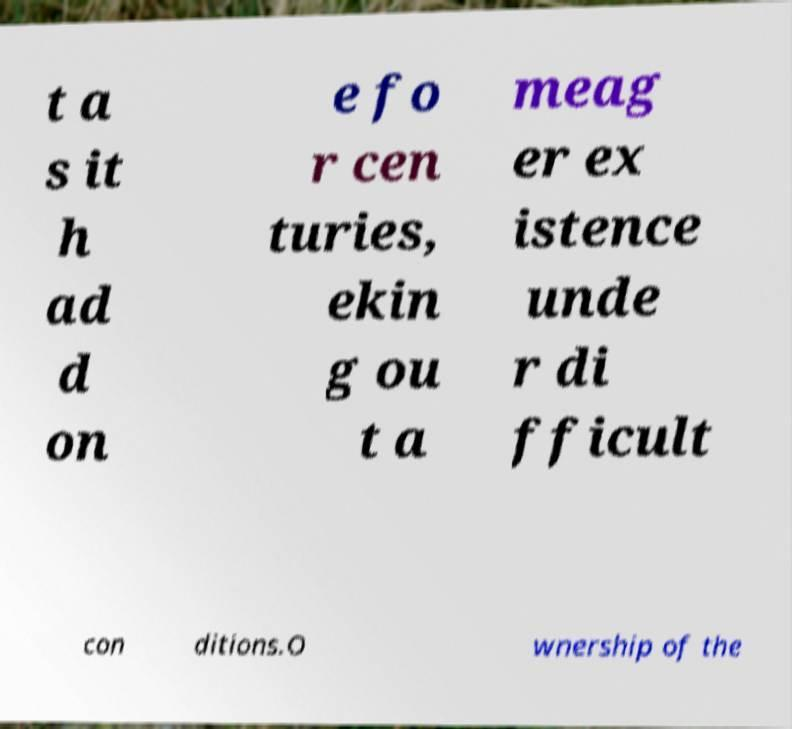I need the written content from this picture converted into text. Can you do that? t a s it h ad d on e fo r cen turies, ekin g ou t a meag er ex istence unde r di fficult con ditions.O wnership of the 